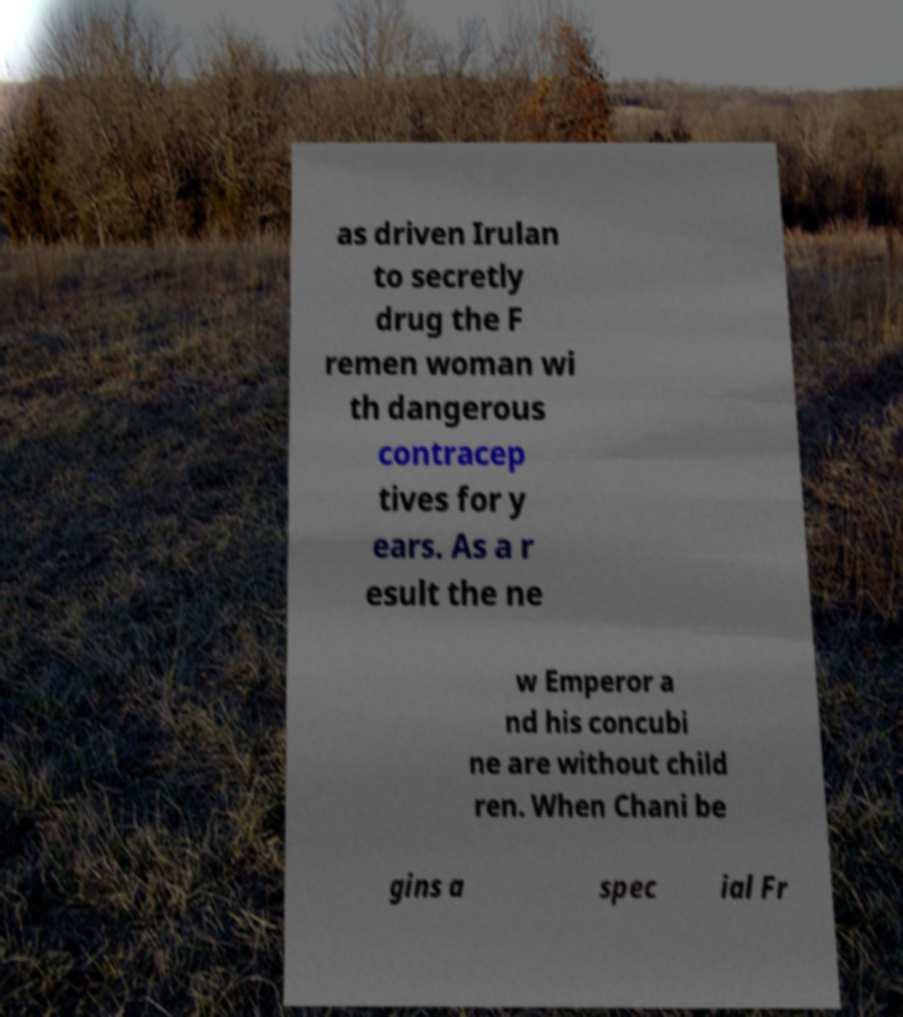Please read and relay the text visible in this image. What does it say? as driven Irulan to secretly drug the F remen woman wi th dangerous contracep tives for y ears. As a r esult the ne w Emperor a nd his concubi ne are without child ren. When Chani be gins a spec ial Fr 